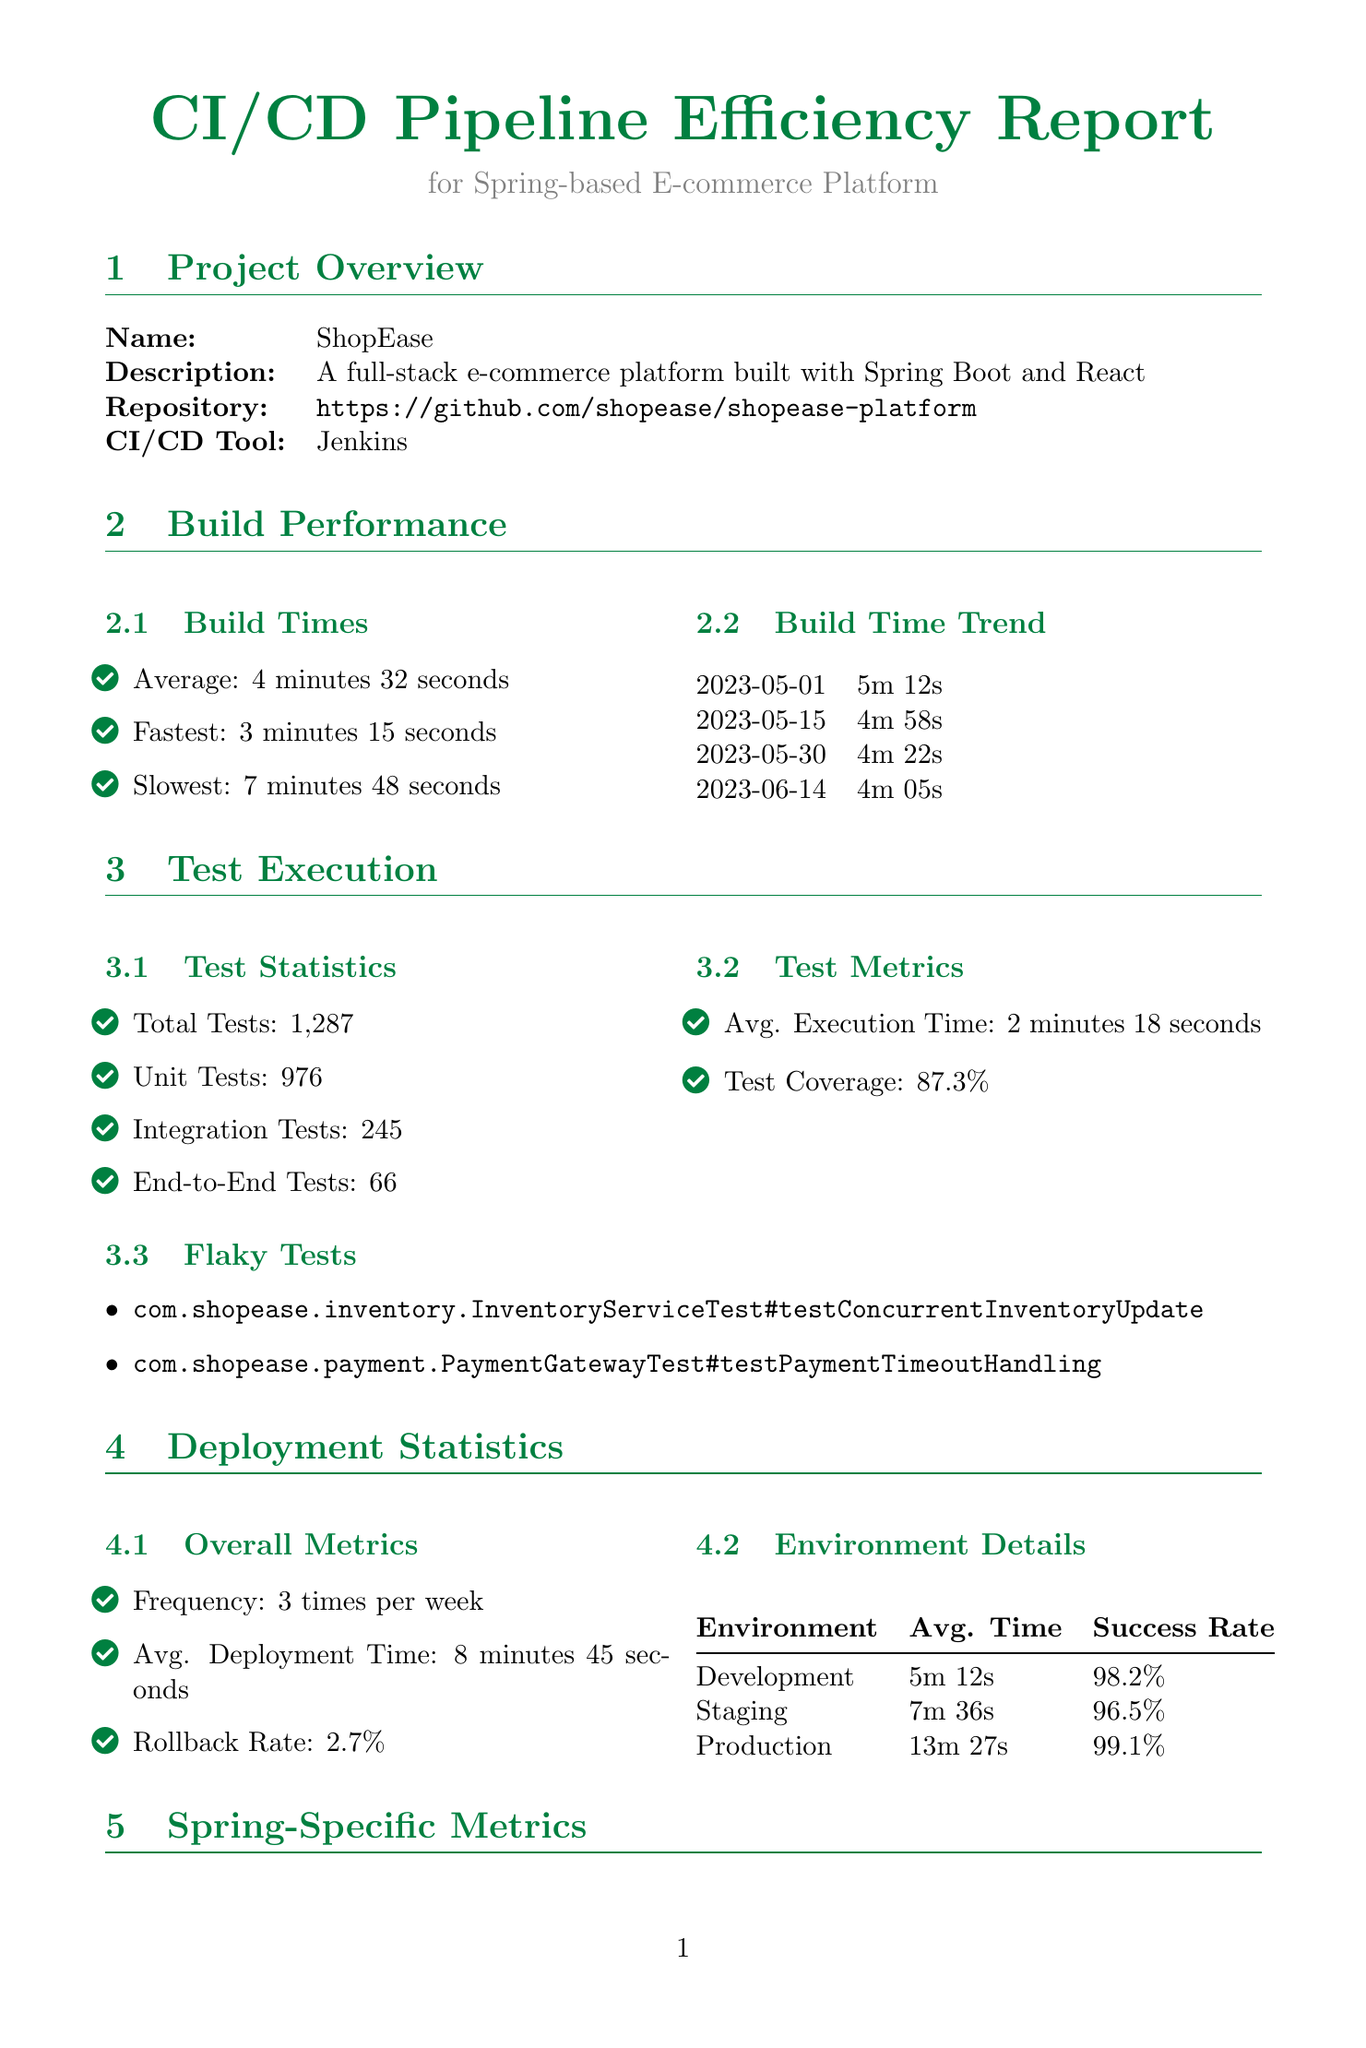What is the average build time? The average build time is stated in the document under "Build Times" as 4 minutes 32 seconds.
Answer: 4 minutes 32 seconds How many total tests were executed? The total number of tests executed is provided in the "Test Statistics" section as 1287.
Answer: 1287 What is the rollback rate? The rollback rate is found in the "Overall Metrics" section, where it states a rollback rate of 2.7%.
Answer: 2.7% What was the fastest build time recorded? The document specifies the fastest build time under "Build Times" as 3 minutes 15 seconds.
Answer: 3 minutes 15 seconds How many times per week does the deployment occur? The deployment frequency is mentioned in the "Overall Metrics" section as 3 times per week.
Answer: 3 times per week What is the expected impact of implementing incremental builds? The expected impact is listed under "Optimization Recommendations" and states a 20% reduction in average build time.
Answer: 20% reduction Which component has an average execution time of 45 seconds? The document identifies the "DatabaseMigrationStep" as having an average execution time of 45 seconds under "Performance Bottlenecks."
Answer: DatabaseMigrationStep What is the success rate for production deployments? The success rate for production deployments is provided in the "Environment Details" section as 99.1%.
Answer: 99.1% What is the severity of the vulnerability found in spring-security-core? The document indicates that the vulnerability found in spring-security-core is of high severity in the "Security Scan Results."
Answer: High 